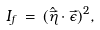Convert formula to latex. <formula><loc_0><loc_0><loc_500><loc_500>I _ { f } \, = \, ( \hat { \vec { \eta } } \cdot \vec { \epsilon } ) ^ { 2 } ,</formula> 